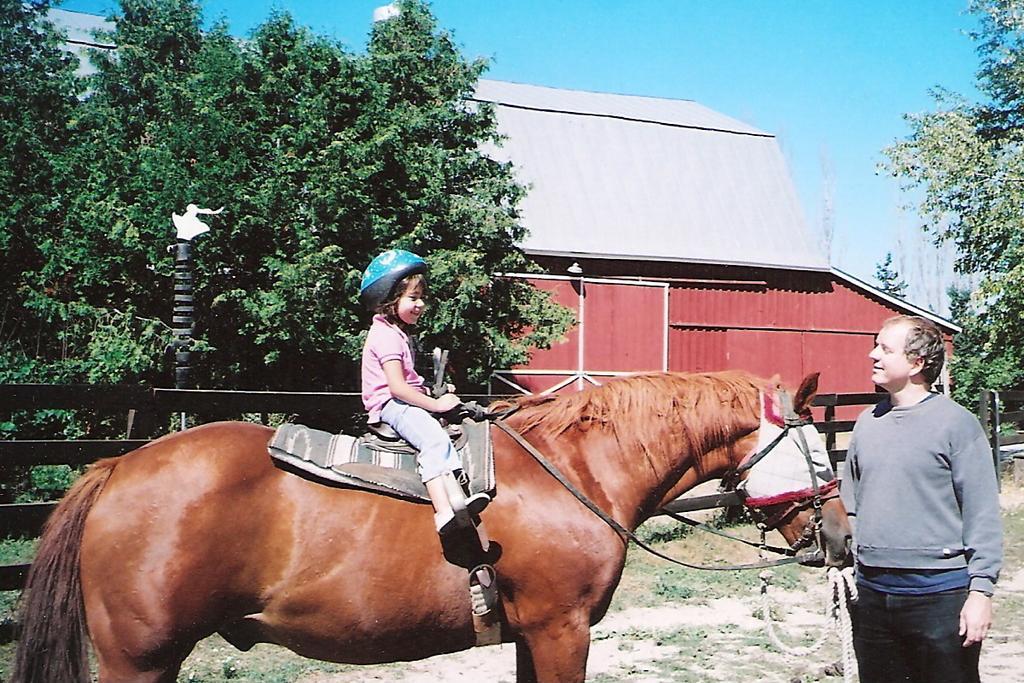Please provide a concise description of this image. This image is clicked outside. There is a sky on the top and trees on left and right side. There is a horse in the middle and a kid is sitting on that horse with helmet on his head and a person on the right side is holding that horse. He is wearing t-shirt and black color pant. 